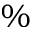<formula> <loc_0><loc_0><loc_500><loc_500>\%</formula> 